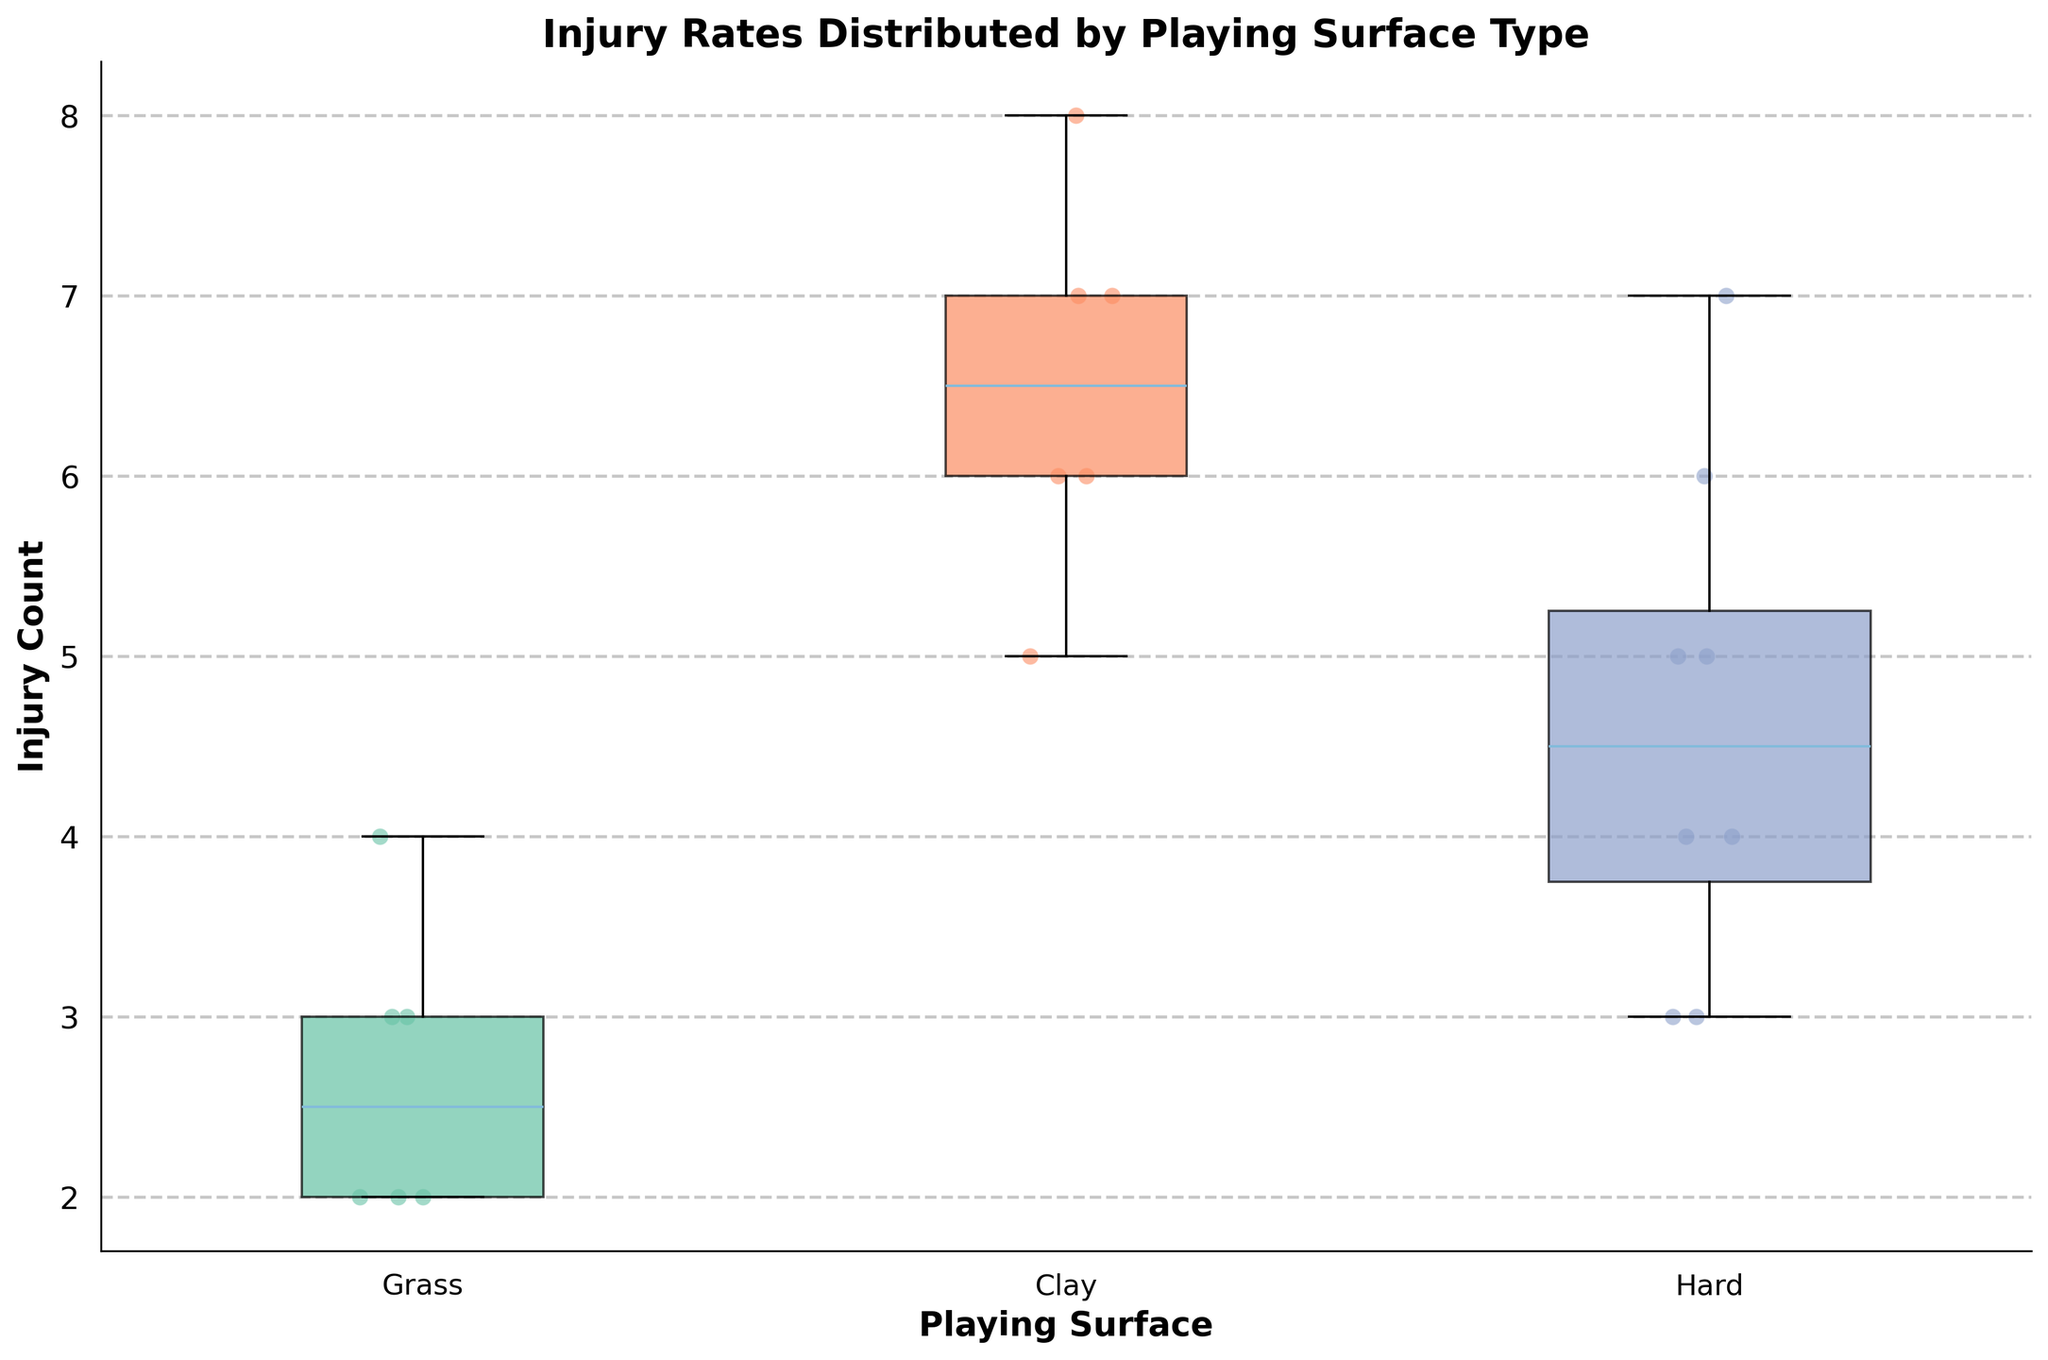What's the title of the plot? The title of the plot can be seen at the top and provides an overview of what the plot is showing.
Answer: Injury Rates Distributed by Playing Surface Type How many different playing surfaces are represented in the plot? The x-axis labels indicate the different playing surfaces used in the plot.
Answer: 3 Which surface type has the widest box? The width of the box represents the number of players for each surface type. The widest box indicates the surface with the most players.
Answer: Hard What is the median injury count for grass surface players? The median is represented by the line inside each box. Look for the line inside the box corresponding to the grass surface.
Answer: 3 Which playing surface shows the highest number of injuries? The maximum value in each box plot, represented by the upper whisker or outlier, indicates the highest number of injuries per surface.
Answer: Clay Compare the spread of injury counts between clay and grass surfaces. Which has a larger spread? The spread can be determined by looking at the range between the lower and upper whiskers of the box plots for clay and grass.
Answer: Clay What is the interquartile range (IQR) for hard surface players? The IQR is the range between the first quartile (Q1) and the third quartile (Q3). Look at where the bottom and top edges of the hard surface box plot lie.
Answer: 2 Are there any outliers in the injury counts for the hard surface, and if so, what are they? Outliers are typically points that lie beyond the whiskers of the box plot. Look at the hard surface plot for any points outside the whiskers.
Answer: No outliers What is the average injury count for players on the clay surface? Sum up the injury counts of all players on the clay surface and divide by the number of players.
Answer: (7 + 8 + 5 + 6 + 6 + 7) / 6 = 39 / 6 = 6.5 Is there a surface type where the lower whisker is higher than the upper whisker of another surface type? Compare the lower whiskers of one surface type to the upper whiskers of another to see if any lower whisker is above an upper whisker.
Answer: No 